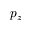Convert formula to latex. <formula><loc_0><loc_0><loc_500><loc_500>p _ { z }</formula> 